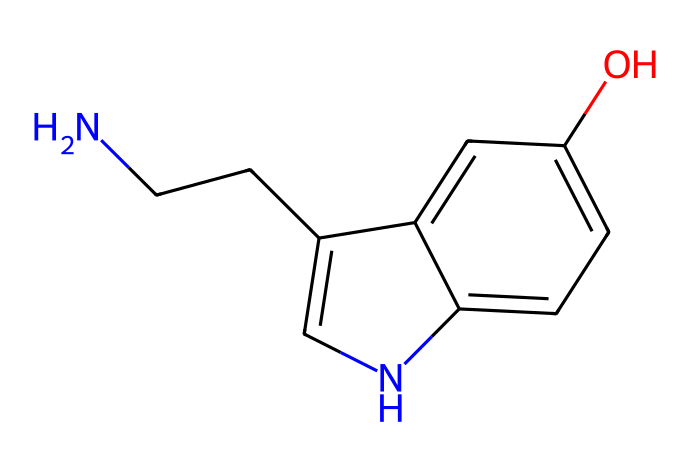What is the primary functional group in serotonin? The chemical structure contains a hydroxyl group (-OH) attached to a benzene ring, which indicates the presence of a phenolic functional group.
Answer: phenolic How many carbon atoms are present in the structure of serotonin? By analyzing the SMILES representation, the chemical structure shows a total of 10 carbon atoms (C).
Answer: 10 What is the total number of nitrogen atoms in serotonin? The SMILES representation indicates one nitrogen atom (N) in the structure of serotonin.
Answer: 1 Which part of serotonin interacts with serotonin receptors? The indole ring system (the fused aromatic ring structure) is crucial for binding to serotonin receptors and exerting biological effects.
Answer: indole ring Is serotonin a primary amine or a secondary amine? The nitrogen in serotonin is connected to two hydrogen atoms and one carbon chain, classifying it as a primary amine.
Answer: primary amine 